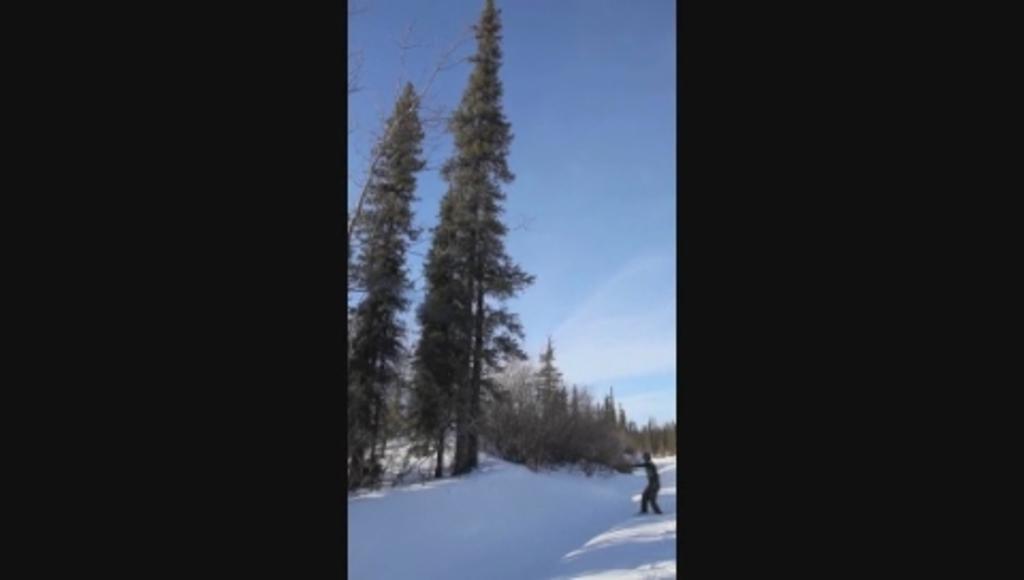Describe this image in one or two sentences. In the picture we can see a snow surface on it, we can see a person standing and in the background, we can see some trees and sky with clouds. 